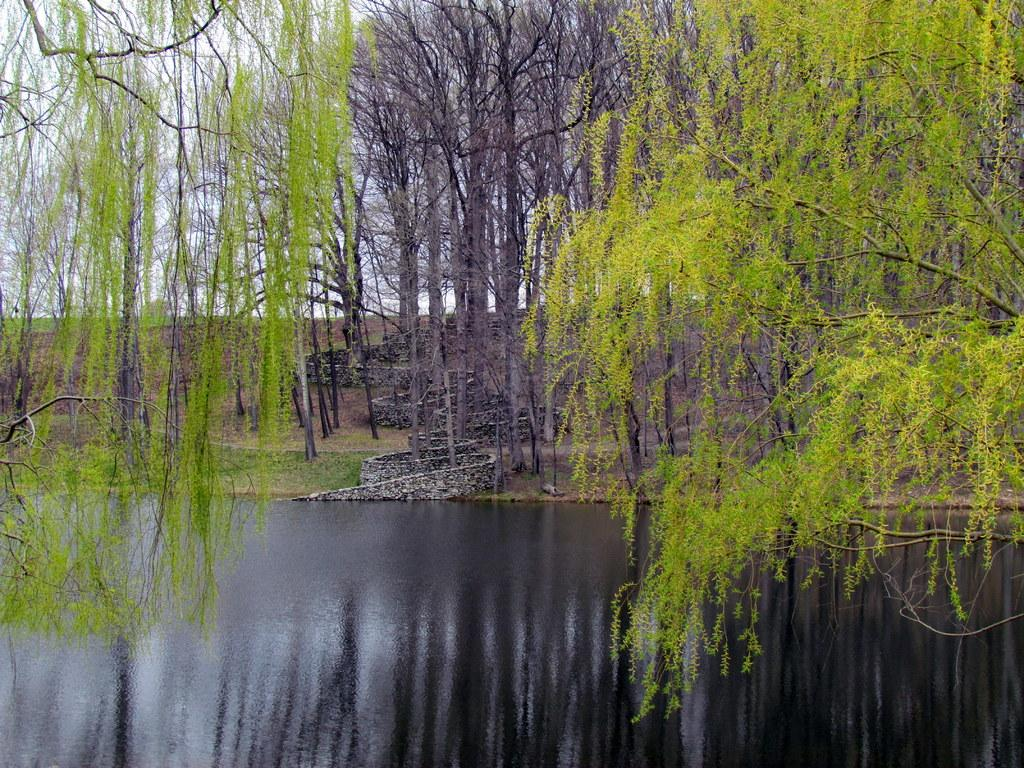What type of vegetation is present in the image? There are many trees in the image. What else can be seen on the ground in the image? There is grass in the image. What is located at the bottom of the image? A: There is water at the bottom of the image. What can be seen in the background of the image? The sky is visible in the background of the image. How many bells are hanging from the trees in the image? There are no bells present in the image; it features trees, grass, water, and the sky. Are there any boats visible in the water at the bottom of the image? There are no boats present in the image; it only shows water at the bottom. 